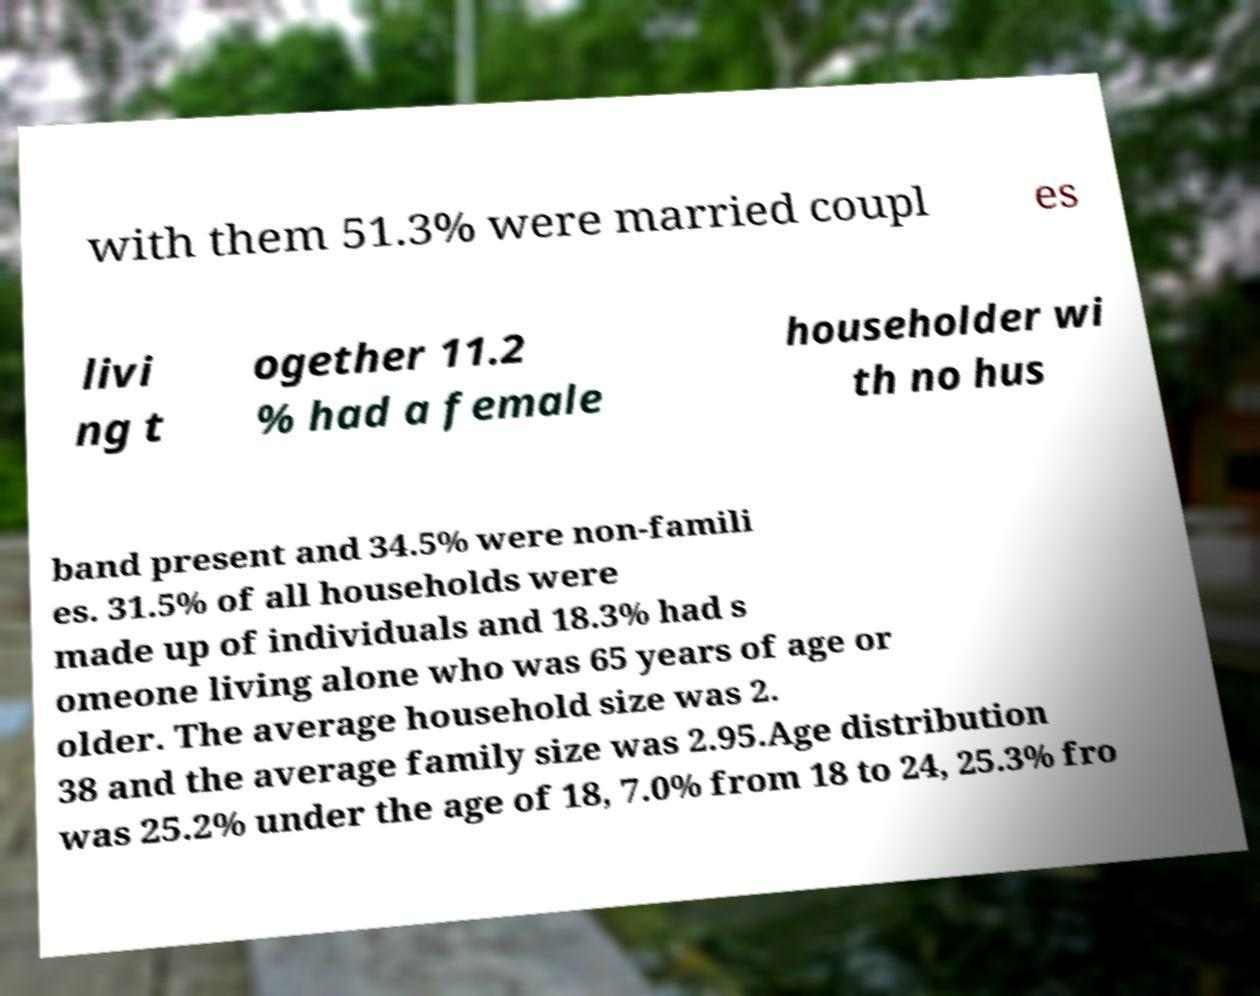Please read and relay the text visible in this image. What does it say? with them 51.3% were married coupl es livi ng t ogether 11.2 % had a female householder wi th no hus band present and 34.5% were non-famili es. 31.5% of all households were made up of individuals and 18.3% had s omeone living alone who was 65 years of age or older. The average household size was 2. 38 and the average family size was 2.95.Age distribution was 25.2% under the age of 18, 7.0% from 18 to 24, 25.3% fro 